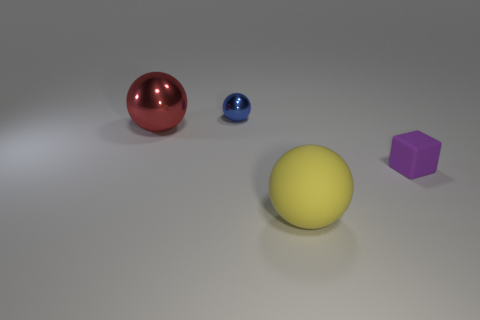Subtract all small metal balls. How many balls are left? 2 Subtract 1 spheres. How many spheres are left? 2 Subtract all yellow balls. How many balls are left? 2 Add 3 blue rubber cubes. How many objects exist? 7 Subtract all balls. How many objects are left? 1 Add 3 large yellow rubber blocks. How many large yellow rubber blocks exist? 3 Subtract 0 purple balls. How many objects are left? 4 Subtract all red spheres. Subtract all blue blocks. How many spheres are left? 2 Subtract all small blue rubber blocks. Subtract all small metallic objects. How many objects are left? 3 Add 1 blue metallic objects. How many blue metallic objects are left? 2 